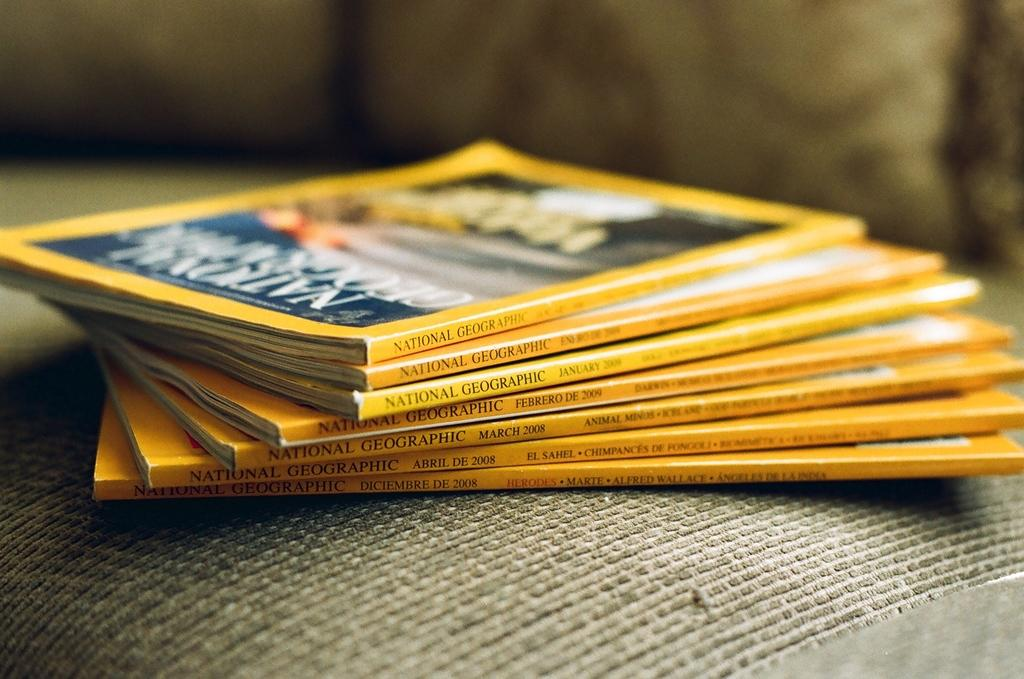<image>
Share a concise interpretation of the image provided. Yellow booklets on top of one another and says "National Geographic" on the side. 